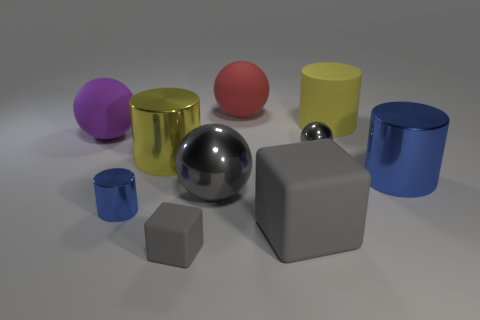Could you describe the lighting in the scene? The lighting in the scene is soft and diffuse, with gentle shadows indicating an overhead light source. The objects exhibit subtle reflections and highlights that suggest a controlled studio environment with possible ambient lighting to reduce harshness. How does the lighting affect the colors of the objects? The soft lighting allows the intrinsic colors of the objects to stand out without causing significant glare or fading. It helps to maintain true-to-life colors, revealing the distinct yellow, blue, red, and purple hues, as well as the metallic and matte finishes without overwhelming brightness or darkness. 